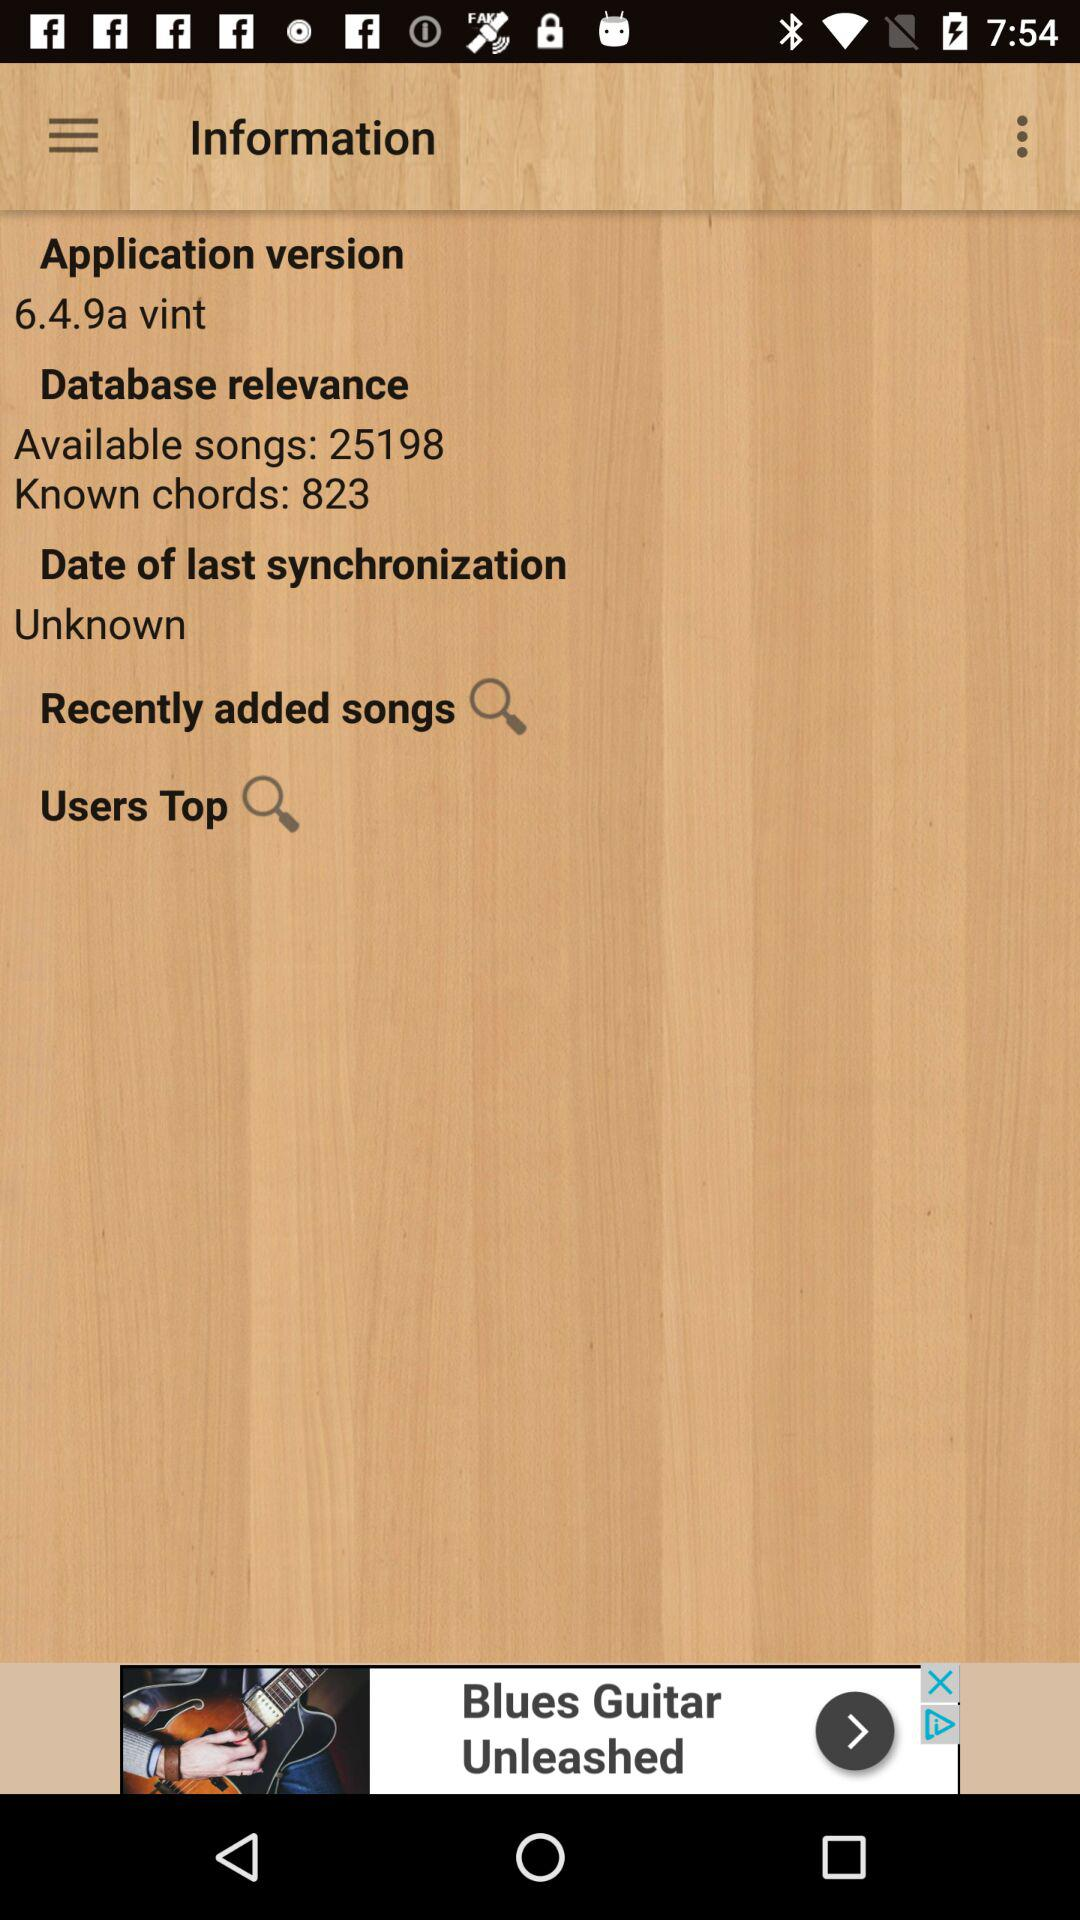How many known chords are there? There are 823 known chords. 